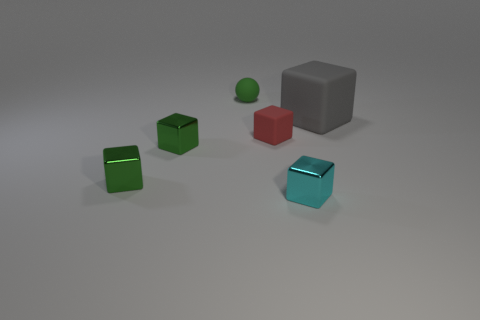Subtract all cyan blocks. How many blocks are left? 4 Subtract all small cyan blocks. How many blocks are left? 4 Subtract all yellow spheres. Subtract all purple blocks. How many spheres are left? 1 Add 1 tiny blue spheres. How many objects exist? 7 Subtract all blocks. How many objects are left? 1 Add 1 big gray things. How many big gray things are left? 2 Add 2 red rubber cubes. How many red rubber cubes exist? 3 Subtract 0 yellow spheres. How many objects are left? 6 Subtract all cyan metallic things. Subtract all large blue cubes. How many objects are left? 5 